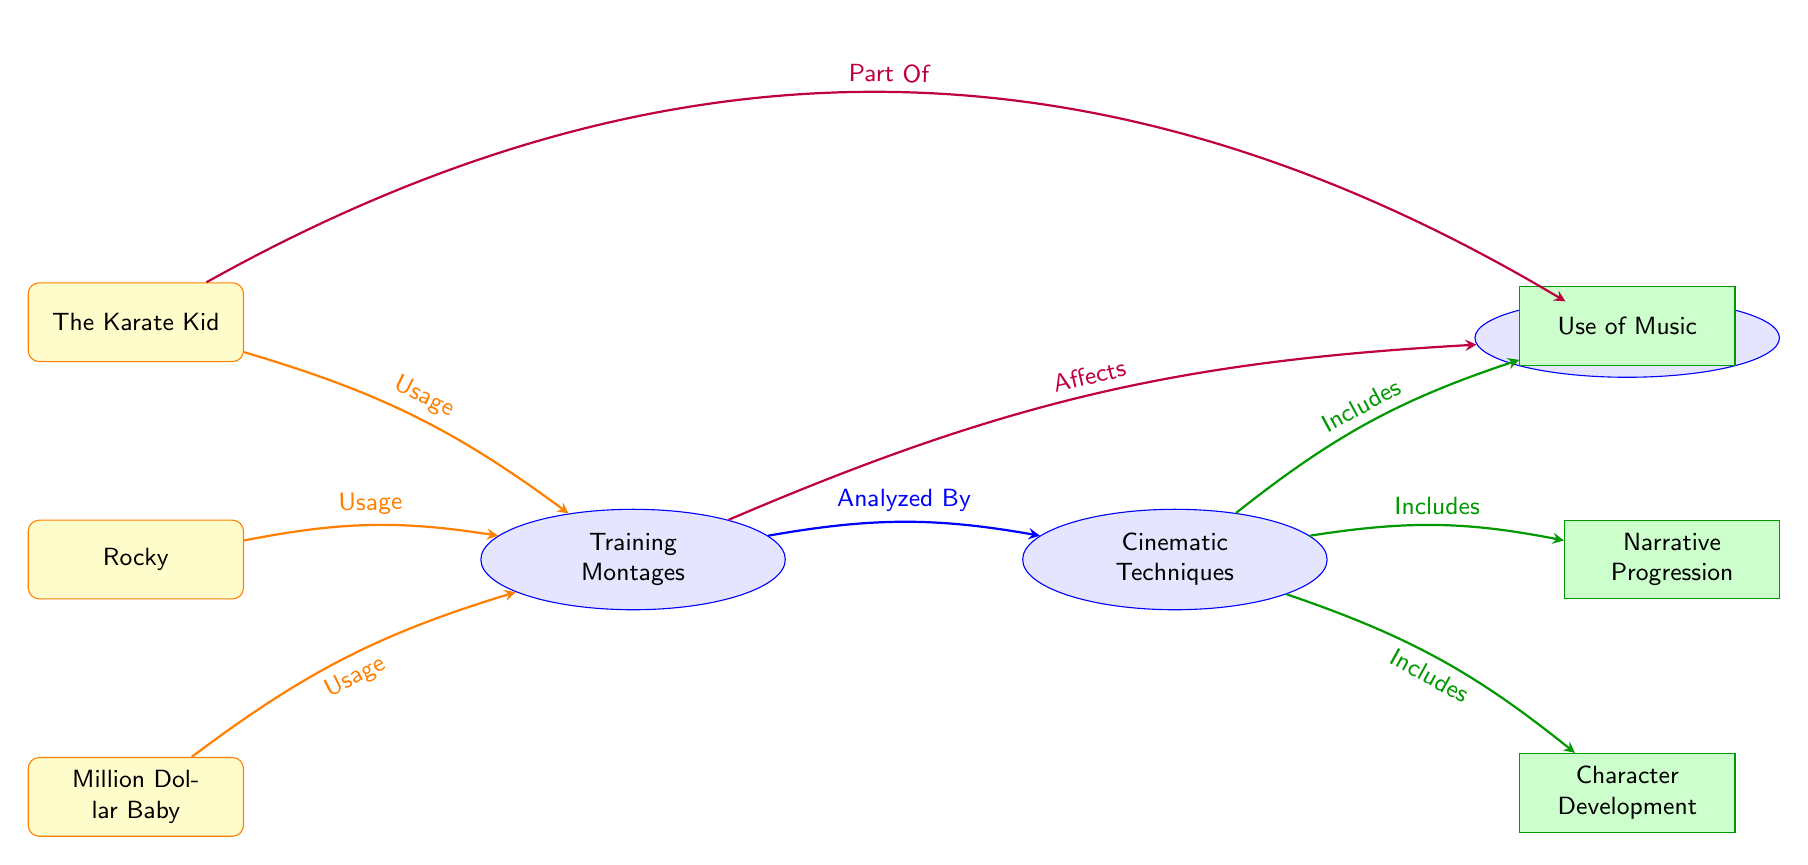What movies are included in the training montages? The movies represented that utilize training montages in the diagram are The Karate Kid, Rocky, and Million Dollar Baby, illustrated by their connections from the training montages node.
Answer: The Karate Kid, Rocky, Million Dollar Baby What is the main concept analyzed in the diagram? The main concept at the center of the diagram that is analyzed is "Cinematic Techniques," which is connected to the training montages and further details regarding techniques.
Answer: Cinematic Techniques How many techniques are included in the cinematic techniques node? There are three techniques listed under the cinematic techniques node in the diagram: Use of Music, Narrative Progression, and Character Development, as indicated by the connections from that node.
Answer: 3 What relationship does training montages have with cultural impact? The diagram illustrates that training montages "Affects" cultural impact, denoted by the arrow connecting those two concepts.
Answer: Affects Which movie is represented as part of the cultural impact? The Karate Kid is the only movie explicitly indicated as "Part Of" the cultural impact within the diagram, which shows a direct relationship from that movie to cultural impact.
Answer: The Karate Kid What is one cinematic technique included in the diagram? The diagram lists several techniques, one of which is "Use of Music," as shown by the direct connection from the cinematic techniques node to this specific technique.
Answer: Use of Music Which movies have usage listed under the training montages? The diagram shows that The Karate Kid, Rocky, and Million Dollar Baby all have a connection indicating their usage of training montages, derived from the arrows pointing to the training montages node.
Answer: The Karate Kid, Rocky, Million Dollar Baby How does the diagram categorize the relationship between training montages and cinematic techniques? The diagram indicates that training montages are analyzed by cinematic techniques, linking the two concepts with a directed connection that establishes this categorization.
Answer: Analyzed By What color represents the cinematic techniques in the diagram? The cinematic techniques node is represented with a green fill color, differentiating it from the other nodes in the diagram.
Answer: Green 